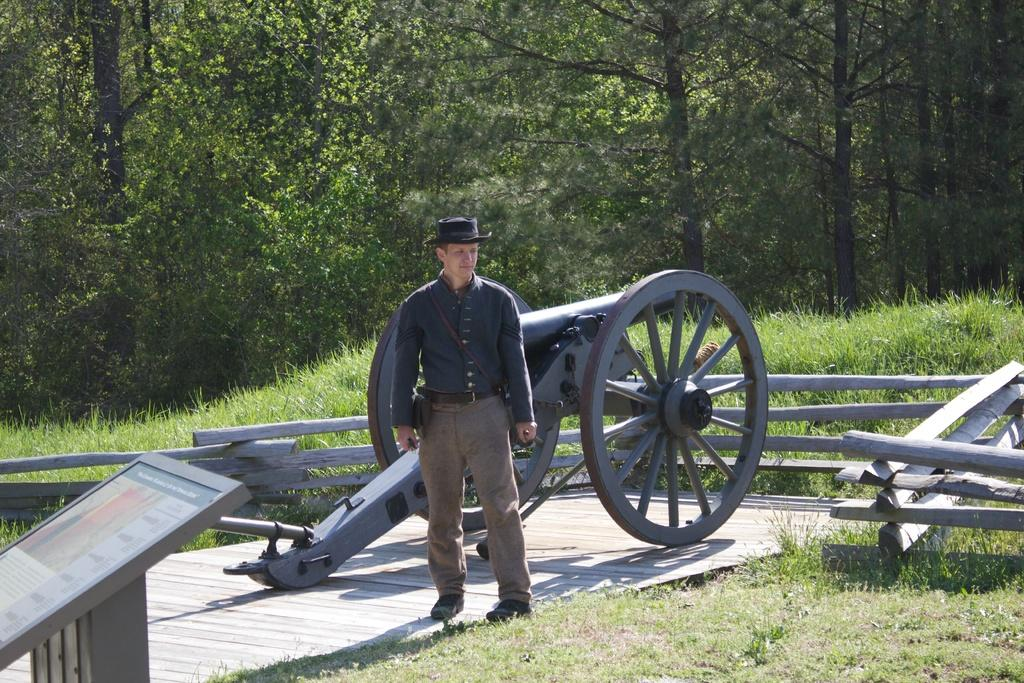What is the person in the image standing in front of? The person is standing in front of a cannon. What can be seen on the ground in the image? There is grass visible in the image. What type of barrier is present in the image? There is a wooden fence in the image. What type of vegetation is visible in the image? There is a group of trees in the image. What type of drink is being served in a mug next to the cannon? There is no mug or drink present in the image. What type of writing instrument is being used by the person standing in front of the cannon? There is no writing instrument visible in the image. 